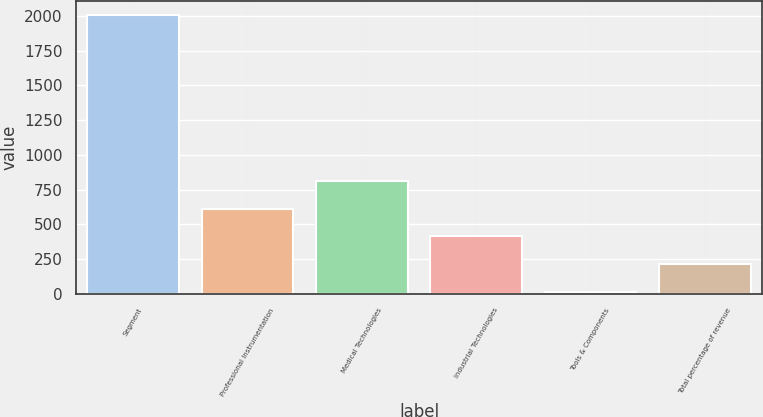<chart> <loc_0><loc_0><loc_500><loc_500><bar_chart><fcel>Segment<fcel>Professional Instrumentation<fcel>Medical Technologies<fcel>Industrial Technologies<fcel>Tools & Components<fcel>Total percentage of revenue<nl><fcel>2006<fcel>611.6<fcel>810.8<fcel>412.4<fcel>14<fcel>213.2<nl></chart> 